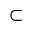<formula> <loc_0><loc_0><loc_500><loc_500>\subset</formula> 